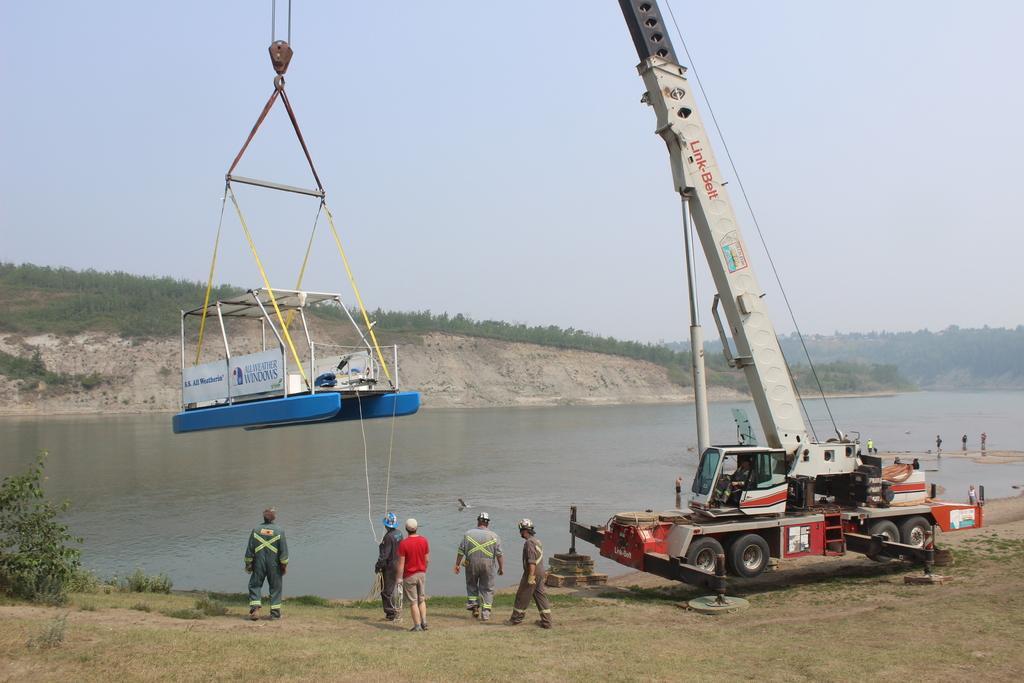How would you summarize this image in a sentence or two? In this image, on the right side, we can see a vehicle which is placed on the land. On the vehicle, we can see a person. In the middle of the image, we can also see a group of people. On the left side, we can see some plants. In the middle of the image, we can also see a crane. In the background, we can see some trees, plants. At the top, we can see a sky, at the bottom, we can see some stones, water in a lake and a grass. 